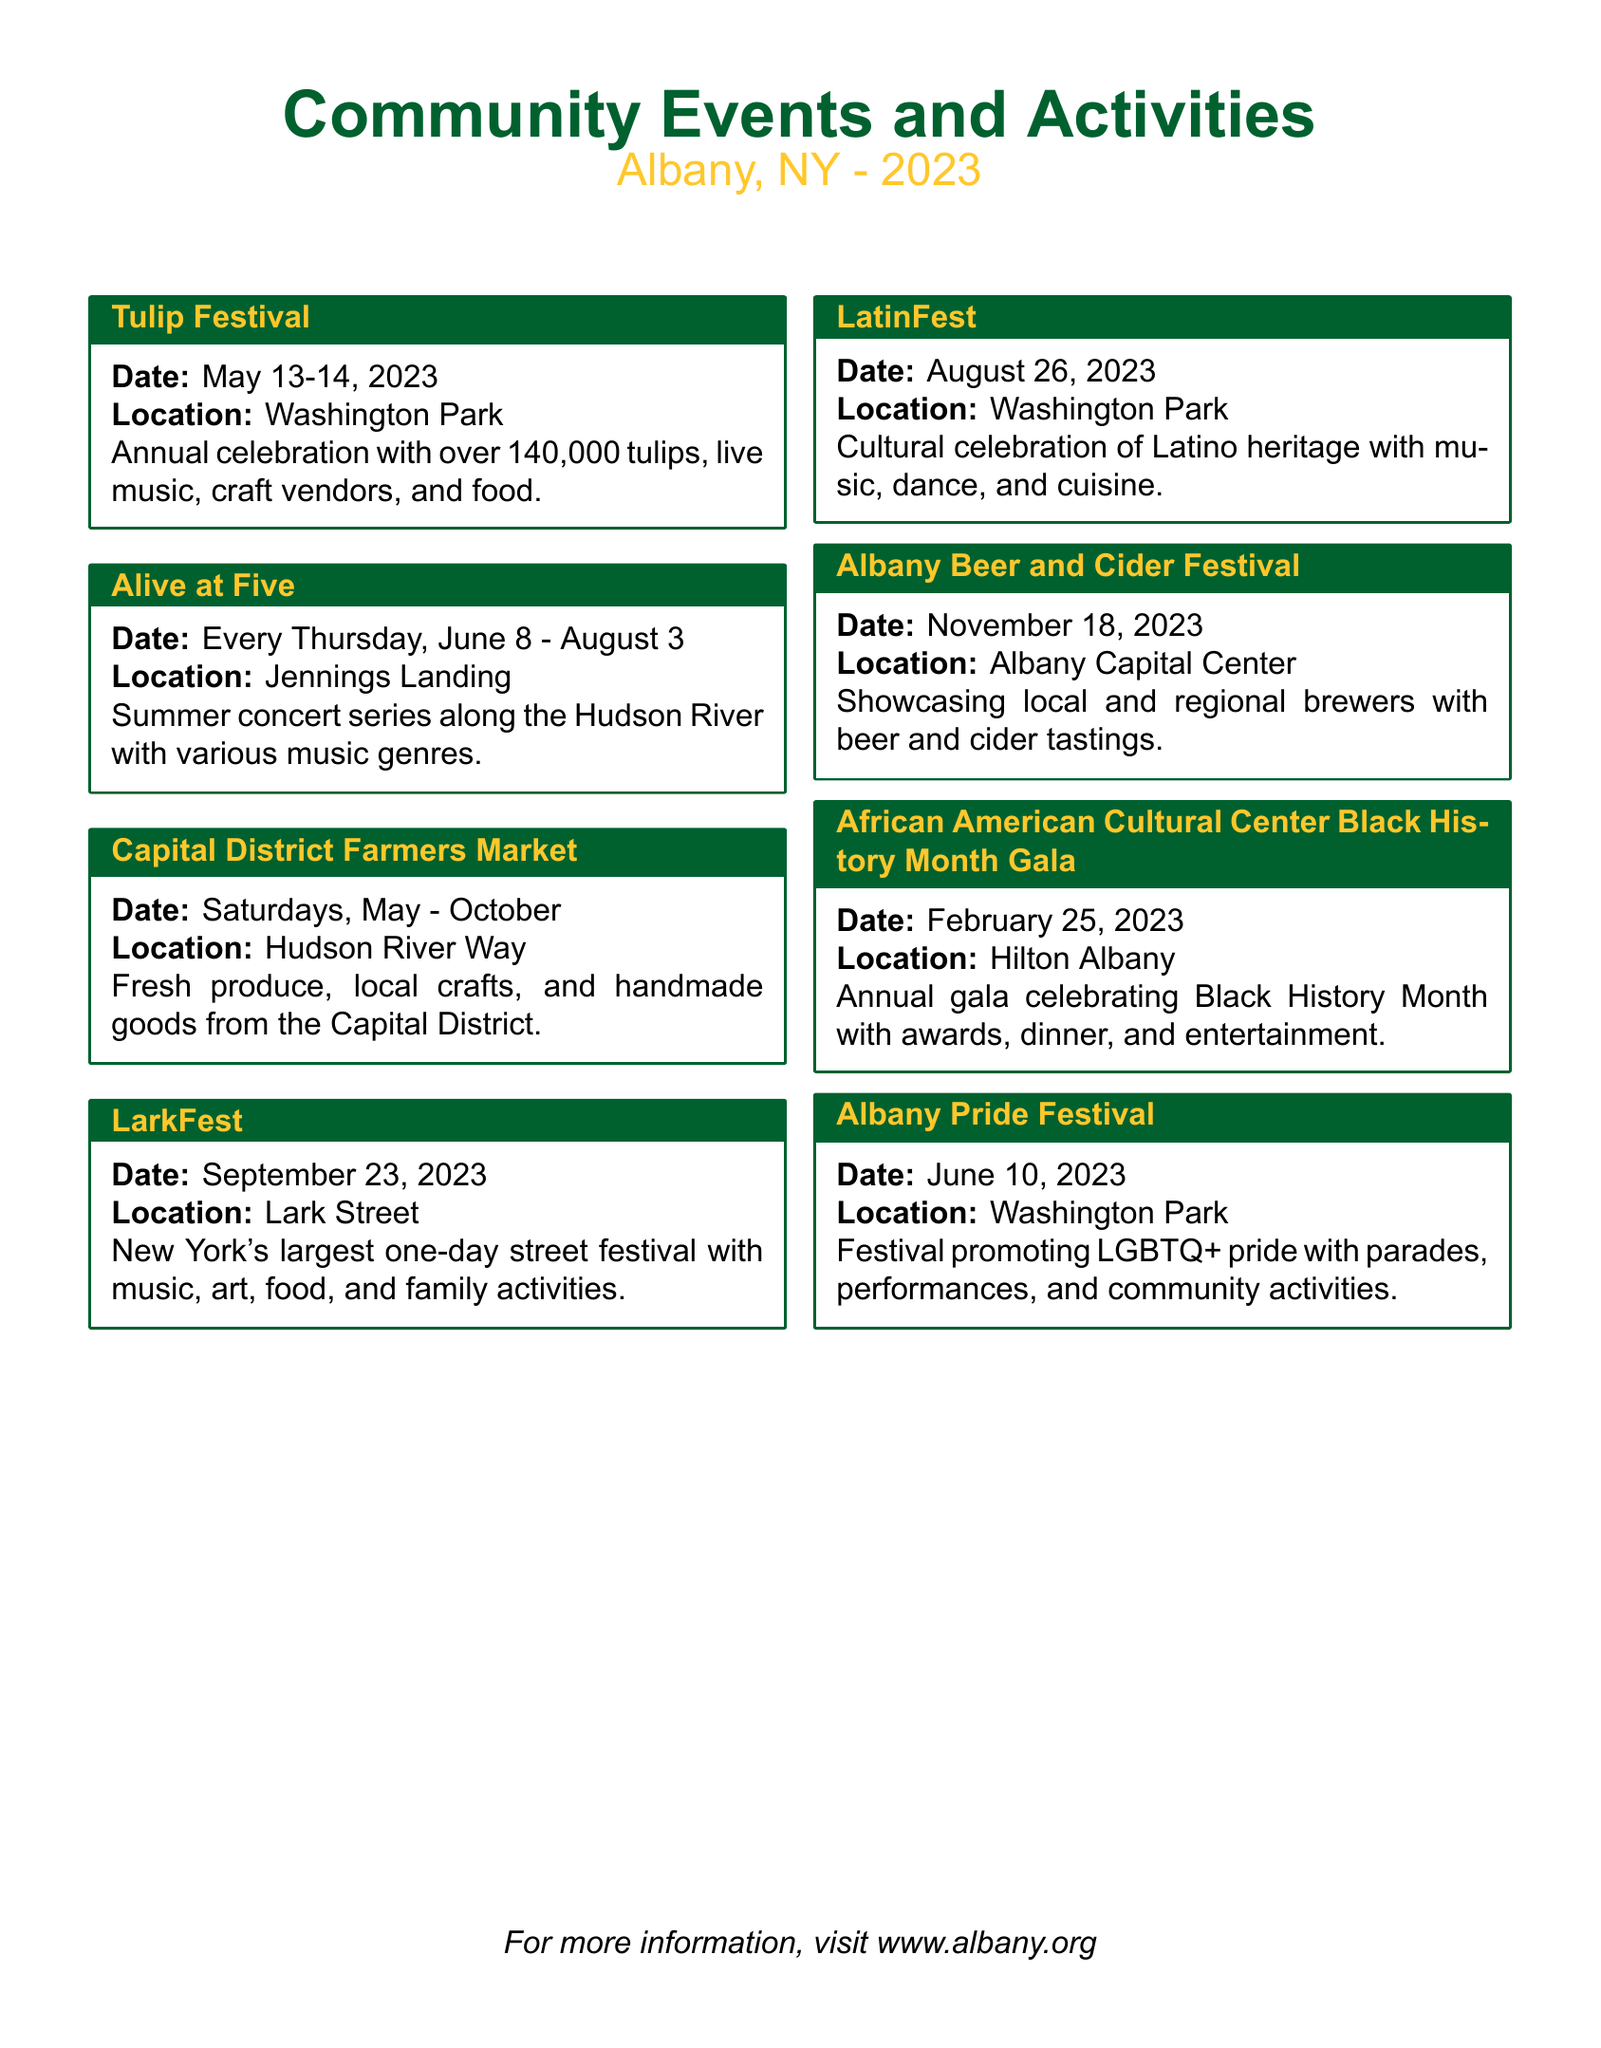how often does the Capital District Farmers Market occur? The Capital District Farmers Market takes place every Saturday from May to October.
Answer: Saturdays which event features Latino culture? The event that celebrates Latino heritage is the LatinFest.
Answer: LatinFest what month is the Albany Pride Festival? The Albany Pride Festival is in June.
Answer: June how many days does LarkFest last? The LarkFest is a one-day street festival.
Answer: One day what type of event is the African American Cultural Center Black History Month Gala? It is an annual gala celebrating Black History Month.
Answer: Annual gala what is showcased at the Albany Beer and Cider Festival? The Albany Beer and Cider Festival showcases local and regional brewers.
Answer: Local and regional brewers 